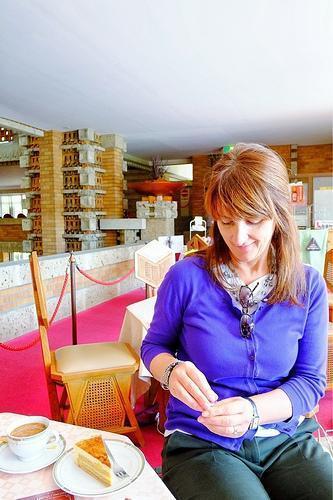How many people are in the photo?
Give a very brief answer. 1. 